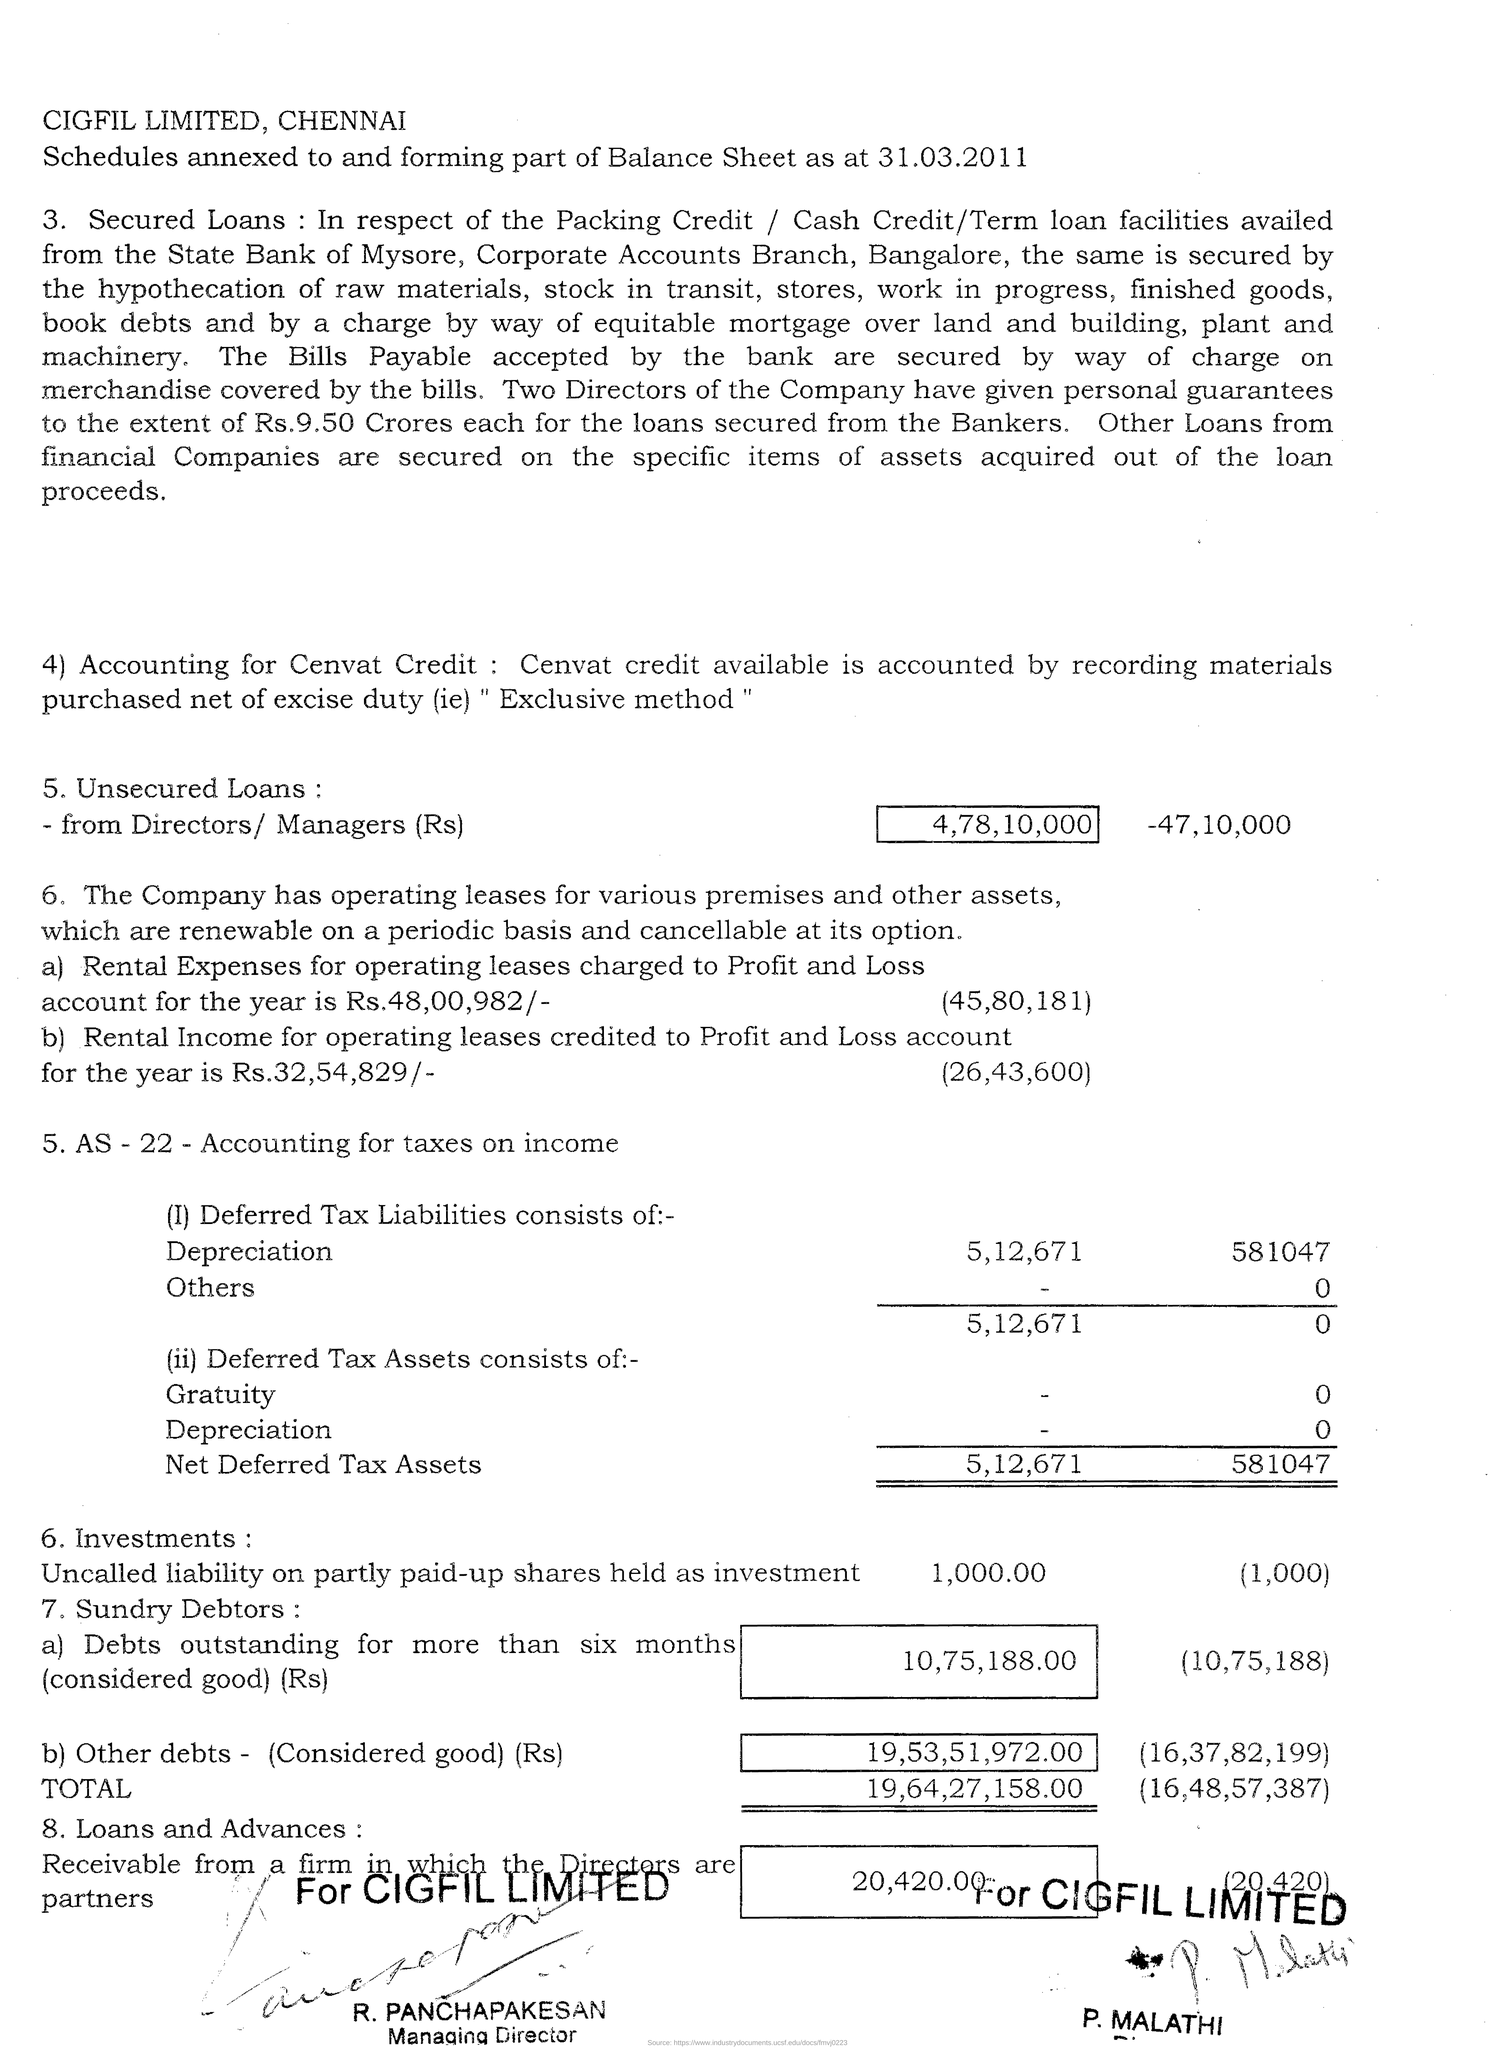Where is cigfil limited located?
Ensure brevity in your answer.  Chennai. Which method is used for availing cenvat credit?
Offer a terse response. Exclusive method. 